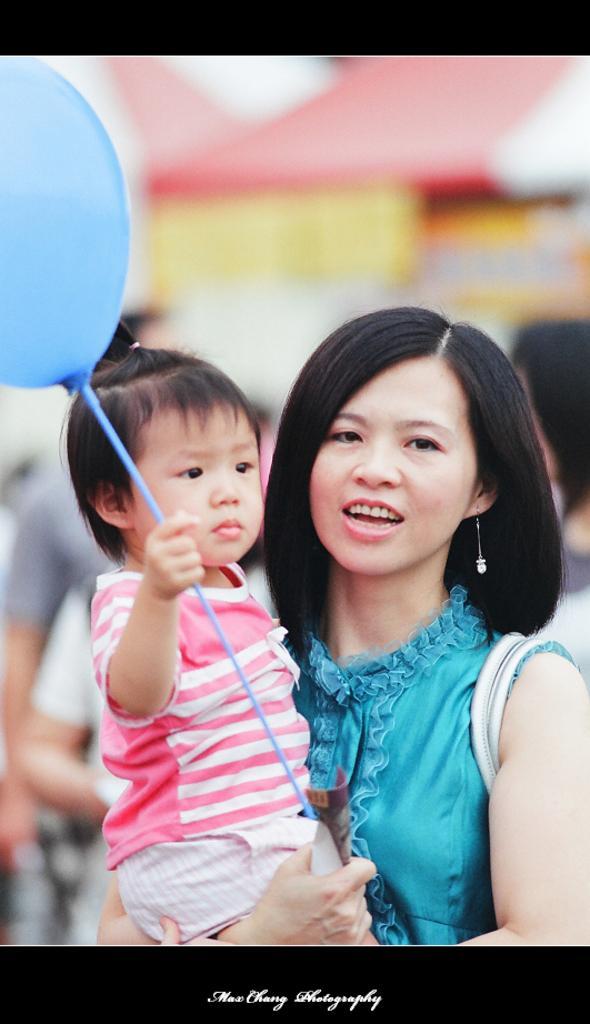Please provide a concise description of this image. The picture consists of a woman in blue dress holding a baby. The baby is holding a balloon. The background is blurred. At the bottom there is text. 